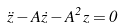Convert formula to latex. <formula><loc_0><loc_0><loc_500><loc_500>\ddot { z } - A \dot { z } - A ^ { 2 } z = 0</formula> 